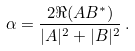<formula> <loc_0><loc_0><loc_500><loc_500>\alpha = \frac { 2 \Re ( A B ^ { \ast } ) } { | A | ^ { 2 } + | B | ^ { 2 } } \, .</formula> 